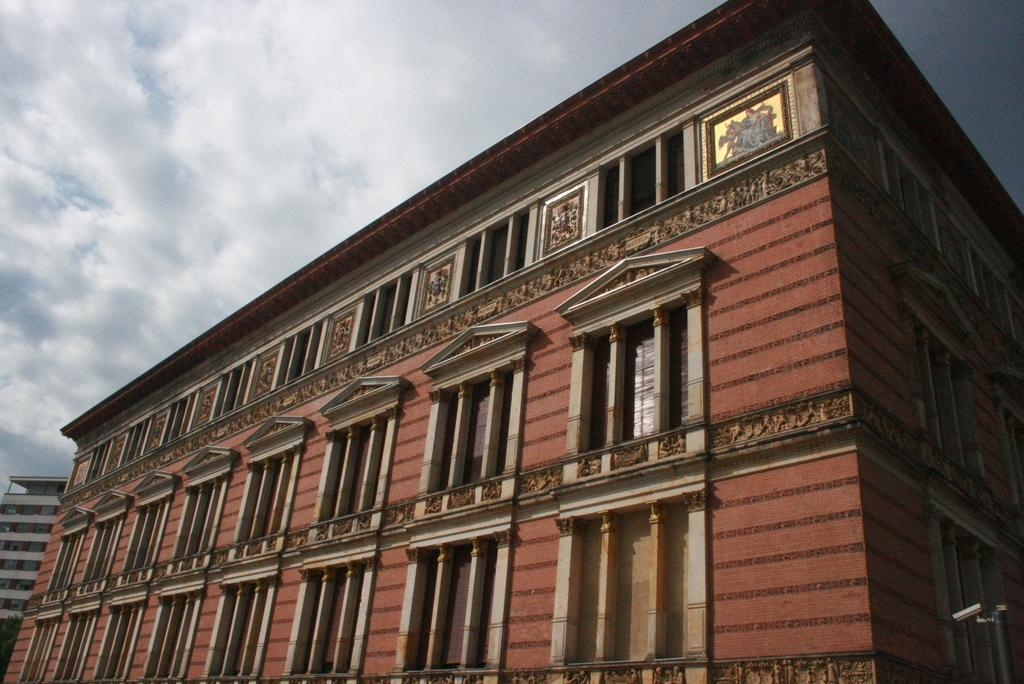What is the main subject in the center of the image? There is a building in the center of the image. What features can be observed on the building? The building has windows. What can be seen in the bottom right side of the image? There appears to be a pole in the bottom right side of the image. What else is visible in the background of the image? There is another building and the sky in the background of the image. What type of agreement is being signed in the image? There is no indication of an agreement or any signing activity in the image. What attempt is being made to start the building in the image? The image does not show any attempt to start the building, as it appears to be a completed structure with windows. 